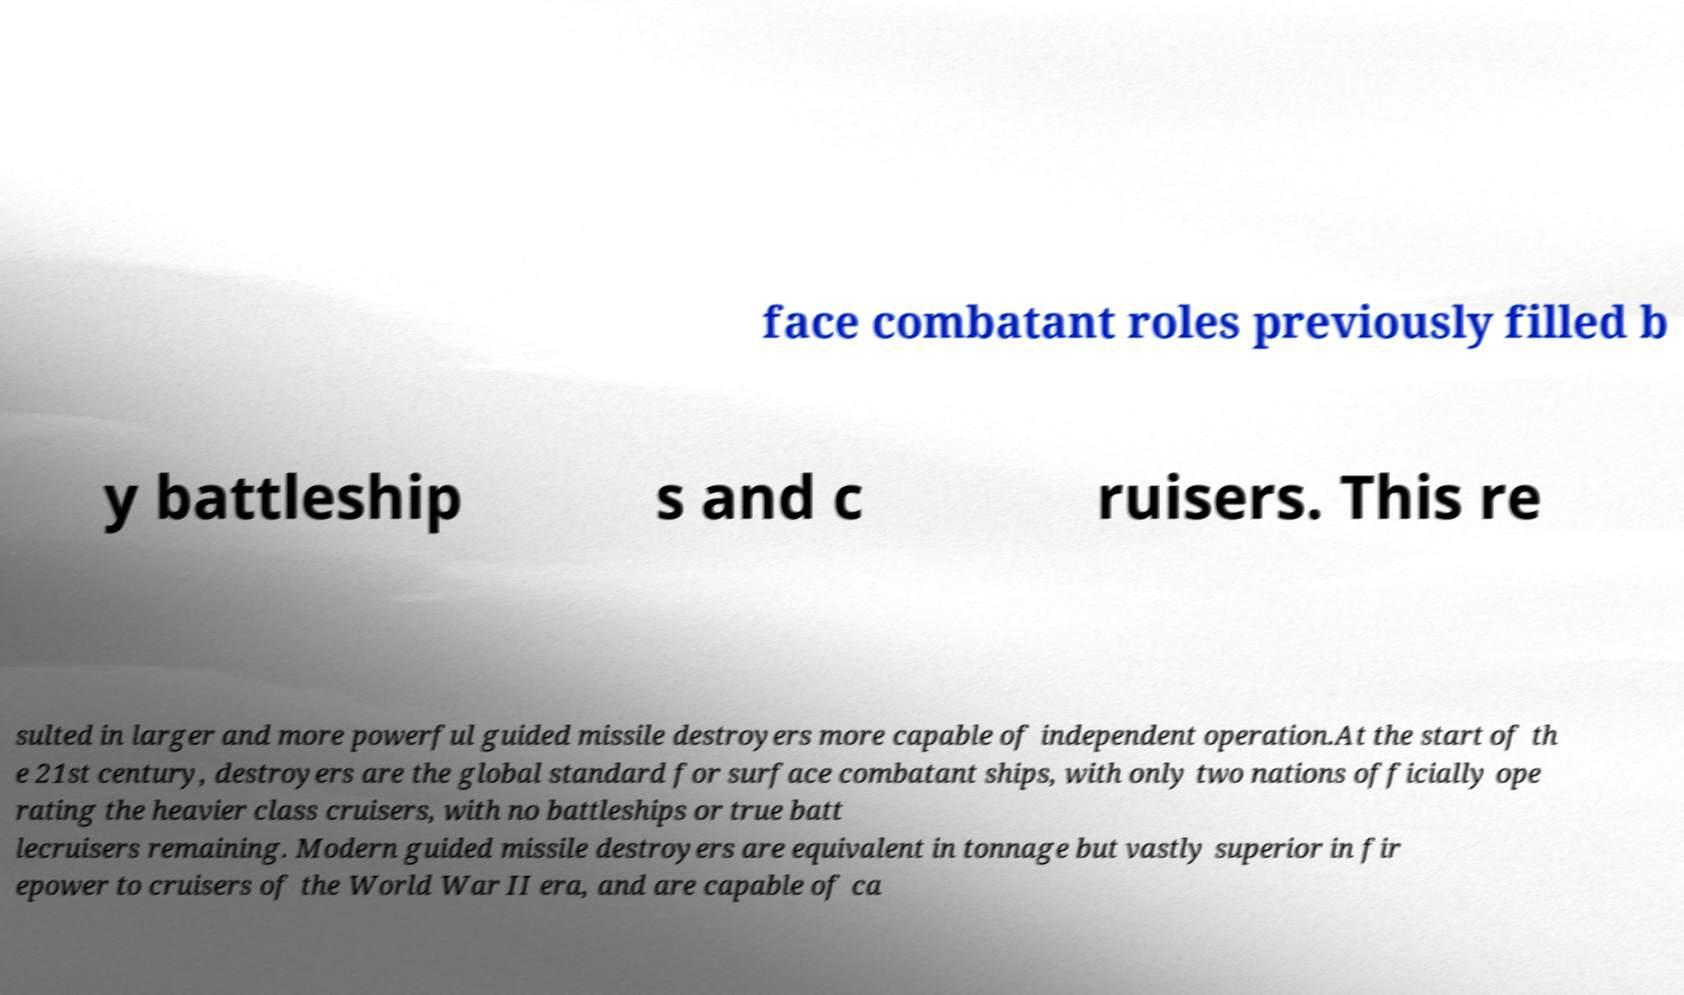Please read and relay the text visible in this image. What does it say? face combatant roles previously filled b y battleship s and c ruisers. This re sulted in larger and more powerful guided missile destroyers more capable of independent operation.At the start of th e 21st century, destroyers are the global standard for surface combatant ships, with only two nations officially ope rating the heavier class cruisers, with no battleships or true batt lecruisers remaining. Modern guided missile destroyers are equivalent in tonnage but vastly superior in fir epower to cruisers of the World War II era, and are capable of ca 